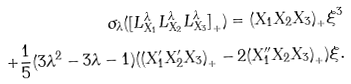<formula> <loc_0><loc_0><loc_500><loc_500>\sigma _ { \lambda } ( { [ L _ { X _ { 1 } } ^ { \lambda } L _ { X _ { 2 } } ^ { \lambda } L _ { X _ { 3 } } ^ { \lambda } ] } _ { + } ) = { ( { X _ { 1 } } { X _ { 2 } } { X _ { 3 } } ) } _ { + } \xi ^ { 3 } \\ + \frac { 1 } { 5 } ( 3 \lambda ^ { 2 } - 3 \lambda - 1 ) ( { ( X _ { 1 } ^ { \prime } X _ { 2 } ^ { \prime } X _ { 3 } ) } _ { + } - 2 { ( X _ { 1 } ^ { \prime \prime } X _ { 2 } X _ { 3 } ) } _ { + } ) \xi .</formula> 